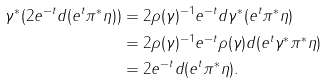Convert formula to latex. <formula><loc_0><loc_0><loc_500><loc_500>\gamma ^ { * } ( 2 e ^ { - t } d ( e ^ { t } \pi ^ { * } \eta ) ) & = 2 \rho ( \gamma ) ^ { - 1 } e ^ { - t } d \gamma ^ { * } ( e ^ { t } \pi ^ { * } \eta ) \\ & = 2 \rho ( \gamma ) ^ { - 1 } e ^ { - t } \rho ( \gamma ) d ( e ^ { t } \gamma ^ { * } \pi ^ { * } \eta ) \\ & = 2 e ^ { - t } d ( e ^ { t } \pi ^ { * } \eta ) .</formula> 